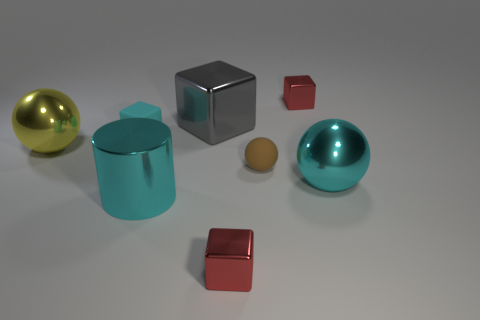There is a metallic cylinder; does it have the same color as the metal ball that is on the right side of the large yellow metallic thing?
Give a very brief answer. Yes. There is a shiny ball that is right of the tiny matte sphere; what is its size?
Provide a succinct answer. Large. How many cyan matte objects are the same size as the cylinder?
Make the answer very short. 0. There is a yellow ball; does it have the same size as the metal cylinder in front of the big gray thing?
Offer a terse response. Yes. How many objects are red cubes or yellow metal objects?
Your answer should be very brief. 3. How many large metallic things are the same color as the tiny rubber block?
Your answer should be very brief. 2. The gray metallic object that is the same size as the yellow metal ball is what shape?
Offer a terse response. Cube. Are there any big things of the same shape as the tiny brown rubber thing?
Provide a short and direct response. Yes. How many red objects are made of the same material as the gray block?
Offer a terse response. 2. Is the material of the red cube in front of the big gray metallic thing the same as the big gray cube?
Your response must be concise. Yes. 